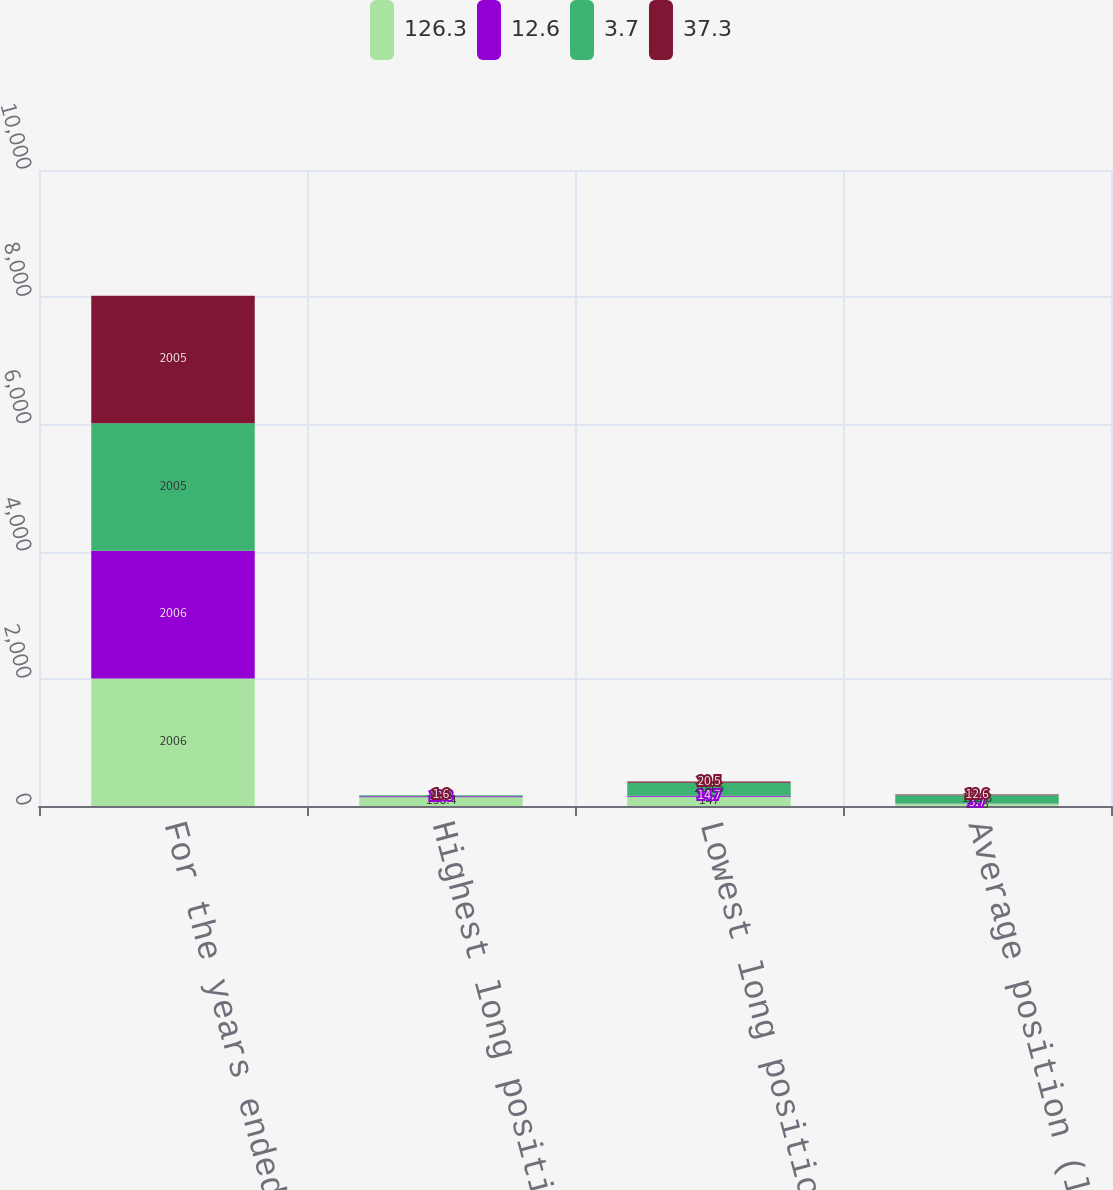<chart> <loc_0><loc_0><loc_500><loc_500><stacked_bar_chart><ecel><fcel>For the years ended December<fcel>Highest long position<fcel>Lowest long position<fcel>Average position (long)<nl><fcel>126.3<fcel>2006<fcel>138.4<fcel>147<fcel>37.3<nl><fcel>12.6<fcel>2006<fcel>13.8<fcel>14.7<fcel>3.7<nl><fcel>3.7<fcel>2005<fcel>16.3<fcel>204.5<fcel>126.3<nl><fcel>37.3<fcel>2005<fcel>1.6<fcel>20.5<fcel>12.6<nl></chart> 